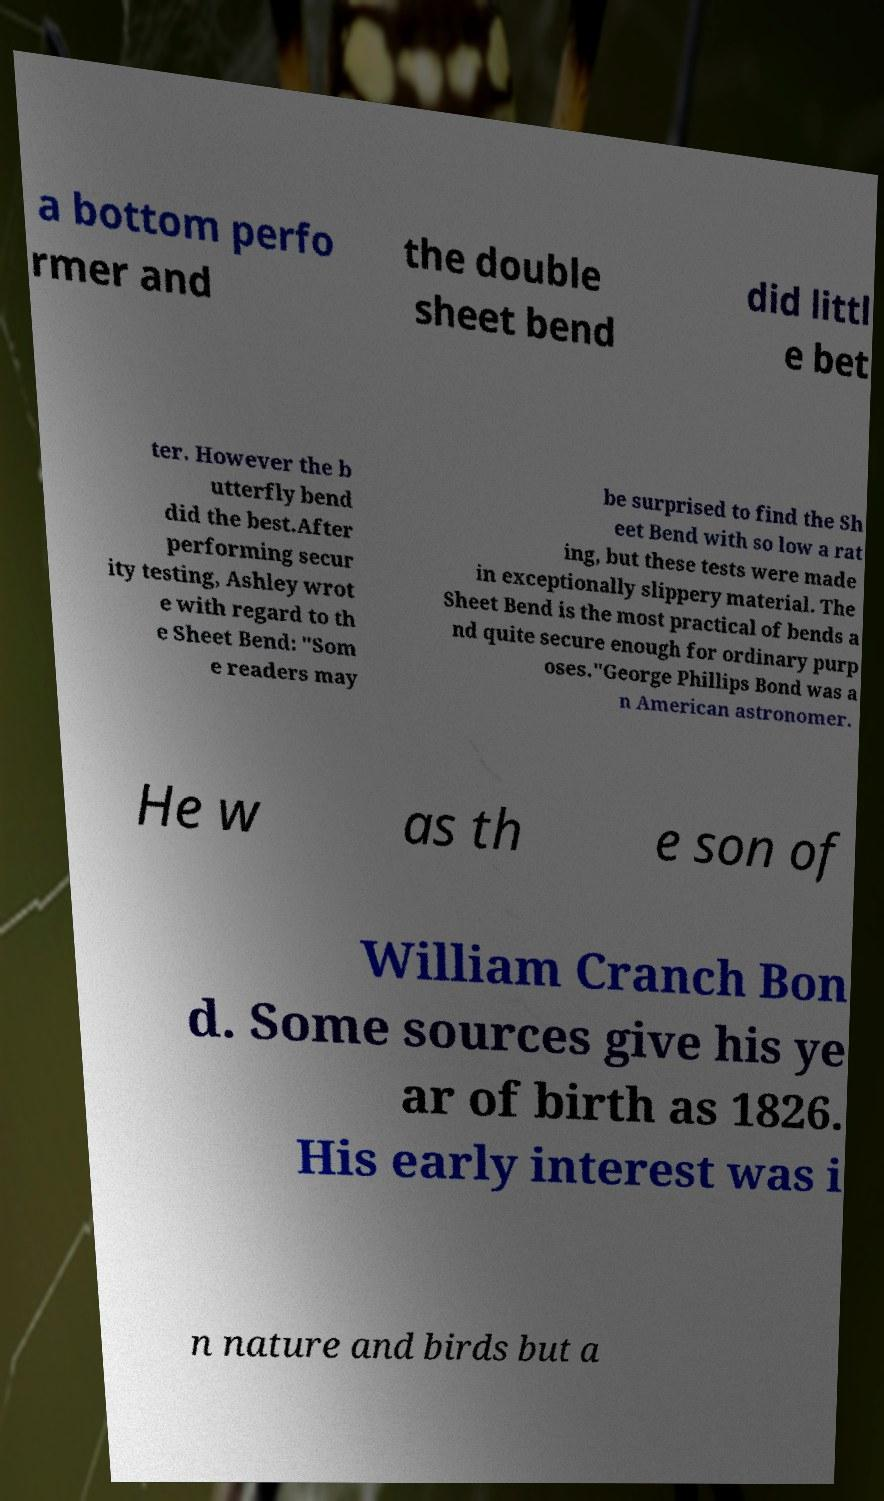Could you extract and type out the text from this image? a bottom perfo rmer and the double sheet bend did littl e bet ter. However the b utterfly bend did the best.After performing secur ity testing, Ashley wrot e with regard to th e Sheet Bend: "Som e readers may be surprised to find the Sh eet Bend with so low a rat ing, but these tests were made in exceptionally slippery material. The Sheet Bend is the most practical of bends a nd quite secure enough for ordinary purp oses."George Phillips Bond was a n American astronomer. He w as th e son of William Cranch Bon d. Some sources give his ye ar of birth as 1826. His early interest was i n nature and birds but a 